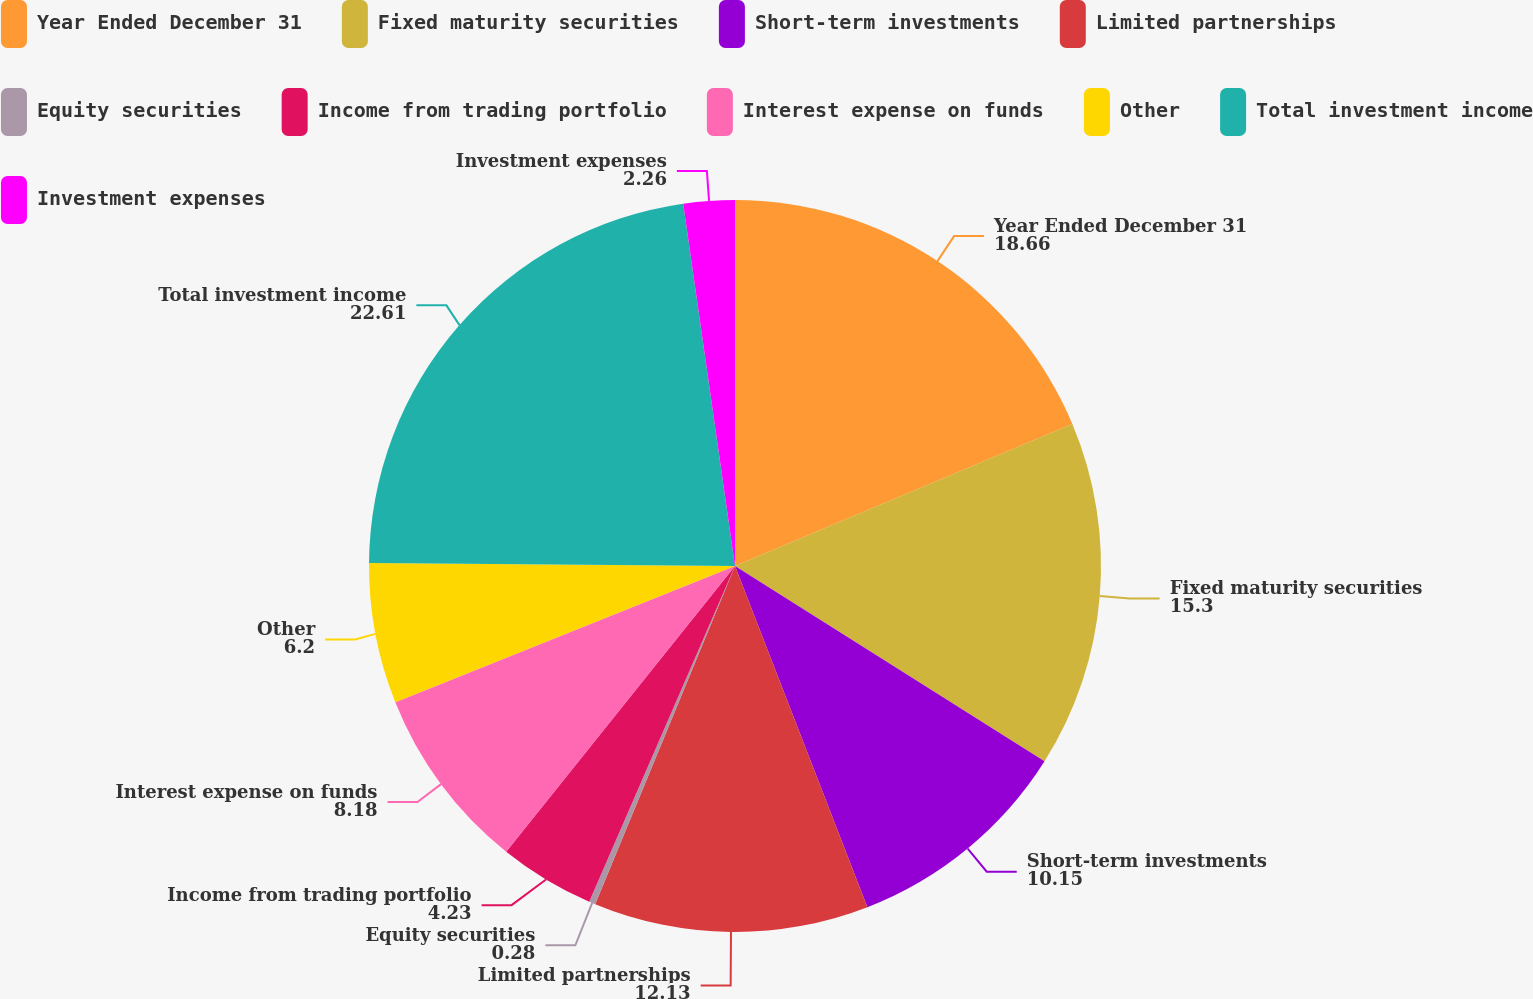Convert chart to OTSL. <chart><loc_0><loc_0><loc_500><loc_500><pie_chart><fcel>Year Ended December 31<fcel>Fixed maturity securities<fcel>Short-term investments<fcel>Limited partnerships<fcel>Equity securities<fcel>Income from trading portfolio<fcel>Interest expense on funds<fcel>Other<fcel>Total investment income<fcel>Investment expenses<nl><fcel>18.66%<fcel>15.3%<fcel>10.15%<fcel>12.13%<fcel>0.28%<fcel>4.23%<fcel>8.18%<fcel>6.2%<fcel>22.61%<fcel>2.26%<nl></chart> 